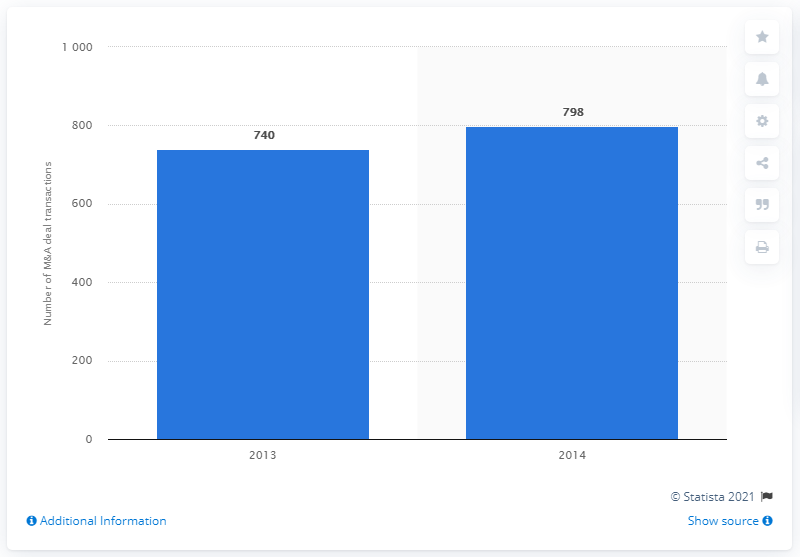What was the deal count in 2014?
 798 